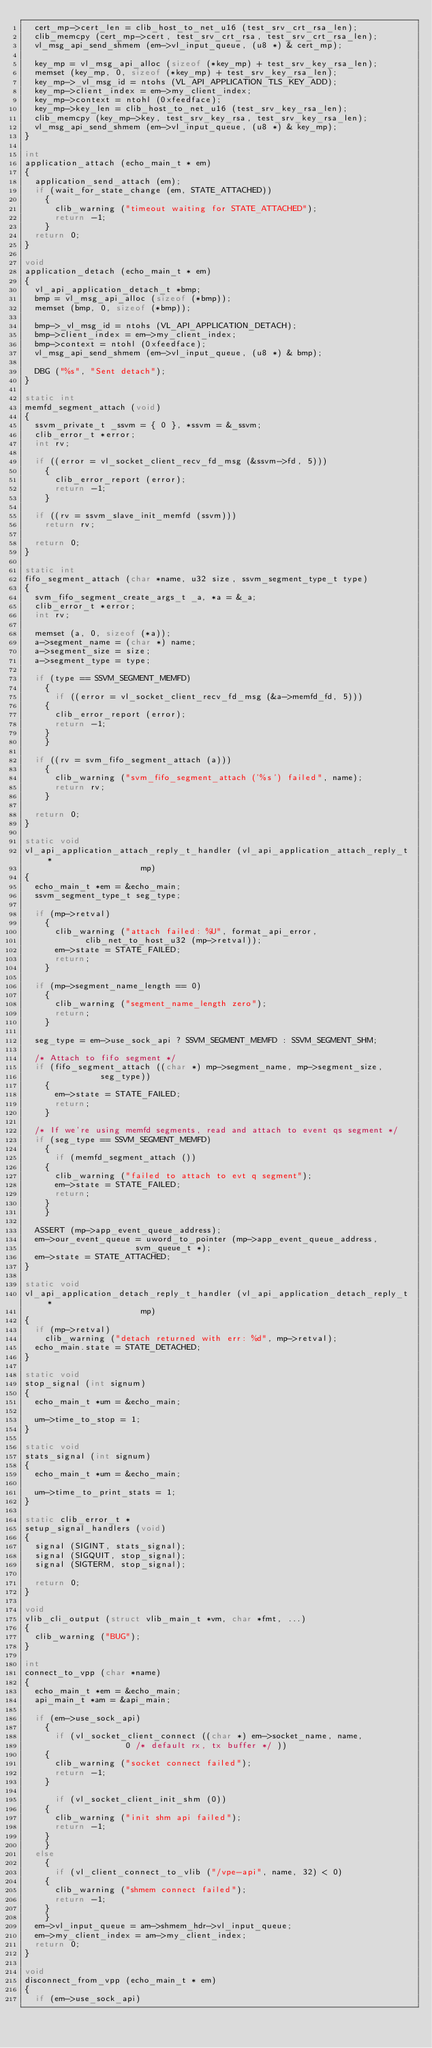Convert code to text. <code><loc_0><loc_0><loc_500><loc_500><_C_>  cert_mp->cert_len = clib_host_to_net_u16 (test_srv_crt_rsa_len);
  clib_memcpy (cert_mp->cert, test_srv_crt_rsa, test_srv_crt_rsa_len);
  vl_msg_api_send_shmem (em->vl_input_queue, (u8 *) & cert_mp);

  key_mp = vl_msg_api_alloc (sizeof (*key_mp) + test_srv_key_rsa_len);
  memset (key_mp, 0, sizeof (*key_mp) + test_srv_key_rsa_len);
  key_mp->_vl_msg_id = ntohs (VL_API_APPLICATION_TLS_KEY_ADD);
  key_mp->client_index = em->my_client_index;
  key_mp->context = ntohl (0xfeedface);
  key_mp->key_len = clib_host_to_net_u16 (test_srv_key_rsa_len);
  clib_memcpy (key_mp->key, test_srv_key_rsa, test_srv_key_rsa_len);
  vl_msg_api_send_shmem (em->vl_input_queue, (u8 *) & key_mp);
}

int
application_attach (echo_main_t * em)
{
  application_send_attach (em);
  if (wait_for_state_change (em, STATE_ATTACHED))
    {
      clib_warning ("timeout waiting for STATE_ATTACHED");
      return -1;
    }
  return 0;
}

void
application_detach (echo_main_t * em)
{
  vl_api_application_detach_t *bmp;
  bmp = vl_msg_api_alloc (sizeof (*bmp));
  memset (bmp, 0, sizeof (*bmp));

  bmp->_vl_msg_id = ntohs (VL_API_APPLICATION_DETACH);
  bmp->client_index = em->my_client_index;
  bmp->context = ntohl (0xfeedface);
  vl_msg_api_send_shmem (em->vl_input_queue, (u8 *) & bmp);

  DBG ("%s", "Sent detach");
}

static int
memfd_segment_attach (void)
{
  ssvm_private_t _ssvm = { 0 }, *ssvm = &_ssvm;
  clib_error_t *error;
  int rv;

  if ((error = vl_socket_client_recv_fd_msg (&ssvm->fd, 5)))
    {
      clib_error_report (error);
      return -1;
    }

  if ((rv = ssvm_slave_init_memfd (ssvm)))
    return rv;

  return 0;
}

static int
fifo_segment_attach (char *name, u32 size, ssvm_segment_type_t type)
{
  svm_fifo_segment_create_args_t _a, *a = &_a;
  clib_error_t *error;
  int rv;

  memset (a, 0, sizeof (*a));
  a->segment_name = (char *) name;
  a->segment_size = size;
  a->segment_type = type;

  if (type == SSVM_SEGMENT_MEMFD)
    {
      if ((error = vl_socket_client_recv_fd_msg (&a->memfd_fd, 5)))
	{
	  clib_error_report (error);
	  return -1;
	}
    }

  if ((rv = svm_fifo_segment_attach (a)))
    {
      clib_warning ("svm_fifo_segment_attach ('%s') failed", name);
      return rv;
    }

  return 0;
}

static void
vl_api_application_attach_reply_t_handler (vl_api_application_attach_reply_t *
					   mp)
{
  echo_main_t *em = &echo_main;
  ssvm_segment_type_t seg_type;

  if (mp->retval)
    {
      clib_warning ("attach failed: %U", format_api_error,
		    clib_net_to_host_u32 (mp->retval));
      em->state = STATE_FAILED;
      return;
    }

  if (mp->segment_name_length == 0)
    {
      clib_warning ("segment_name_length zero");
      return;
    }

  seg_type = em->use_sock_api ? SSVM_SEGMENT_MEMFD : SSVM_SEGMENT_SHM;

  /* Attach to fifo segment */
  if (fifo_segment_attach ((char *) mp->segment_name, mp->segment_size,
			   seg_type))
    {
      em->state = STATE_FAILED;
      return;
    }

  /* If we're using memfd segments, read and attach to event qs segment */
  if (seg_type == SSVM_SEGMENT_MEMFD)
    {
      if (memfd_segment_attach ())
	{
	  clib_warning ("failed to attach to evt q segment");
	  em->state = STATE_FAILED;
	  return;
	}
    }

  ASSERT (mp->app_event_queue_address);
  em->our_event_queue = uword_to_pointer (mp->app_event_queue_address,
					  svm_queue_t *);
  em->state = STATE_ATTACHED;
}

static void
vl_api_application_detach_reply_t_handler (vl_api_application_detach_reply_t *
					   mp)
{
  if (mp->retval)
    clib_warning ("detach returned with err: %d", mp->retval);
  echo_main.state = STATE_DETACHED;
}

static void
stop_signal (int signum)
{
  echo_main_t *um = &echo_main;

  um->time_to_stop = 1;
}

static void
stats_signal (int signum)
{
  echo_main_t *um = &echo_main;

  um->time_to_print_stats = 1;
}

static clib_error_t *
setup_signal_handlers (void)
{
  signal (SIGINT, stats_signal);
  signal (SIGQUIT, stop_signal);
  signal (SIGTERM, stop_signal);

  return 0;
}

void
vlib_cli_output (struct vlib_main_t *vm, char *fmt, ...)
{
  clib_warning ("BUG");
}

int
connect_to_vpp (char *name)
{
  echo_main_t *em = &echo_main;
  api_main_t *am = &api_main;

  if (em->use_sock_api)
    {
      if (vl_socket_client_connect ((char *) em->socket_name, name,
				    0 /* default rx, tx buffer */ ))
	{
	  clib_warning ("socket connect failed");
	  return -1;
	}

      if (vl_socket_client_init_shm (0))
	{
	  clib_warning ("init shm api failed");
	  return -1;
	}
    }
  else
    {
      if (vl_client_connect_to_vlib ("/vpe-api", name, 32) < 0)
	{
	  clib_warning ("shmem connect failed");
	  return -1;
	}
    }
  em->vl_input_queue = am->shmem_hdr->vl_input_queue;
  em->my_client_index = am->my_client_index;
  return 0;
}

void
disconnect_from_vpp (echo_main_t * em)
{
  if (em->use_sock_api)</code> 